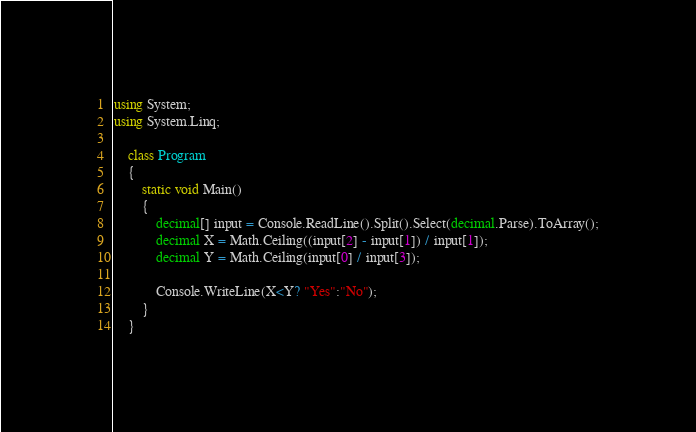Convert code to text. <code><loc_0><loc_0><loc_500><loc_500><_C#_>using System;
using System.Linq;

    class Program
    {
        static void Main()
        {
            decimal[] input = Console.ReadLine().Split().Select(decimal.Parse).ToArray();
            decimal X = Math.Ceiling((input[2] - input[1]) / input[1]);
            decimal Y = Math.Ceiling(input[0] / input[3]);

            Console.WriteLine(X<Y? "Yes":"No");
        }
    }</code> 